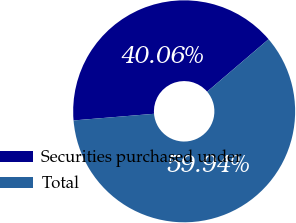Convert chart. <chart><loc_0><loc_0><loc_500><loc_500><pie_chart><fcel>Securities purchased under<fcel>Total<nl><fcel>40.06%<fcel>59.94%<nl></chart> 